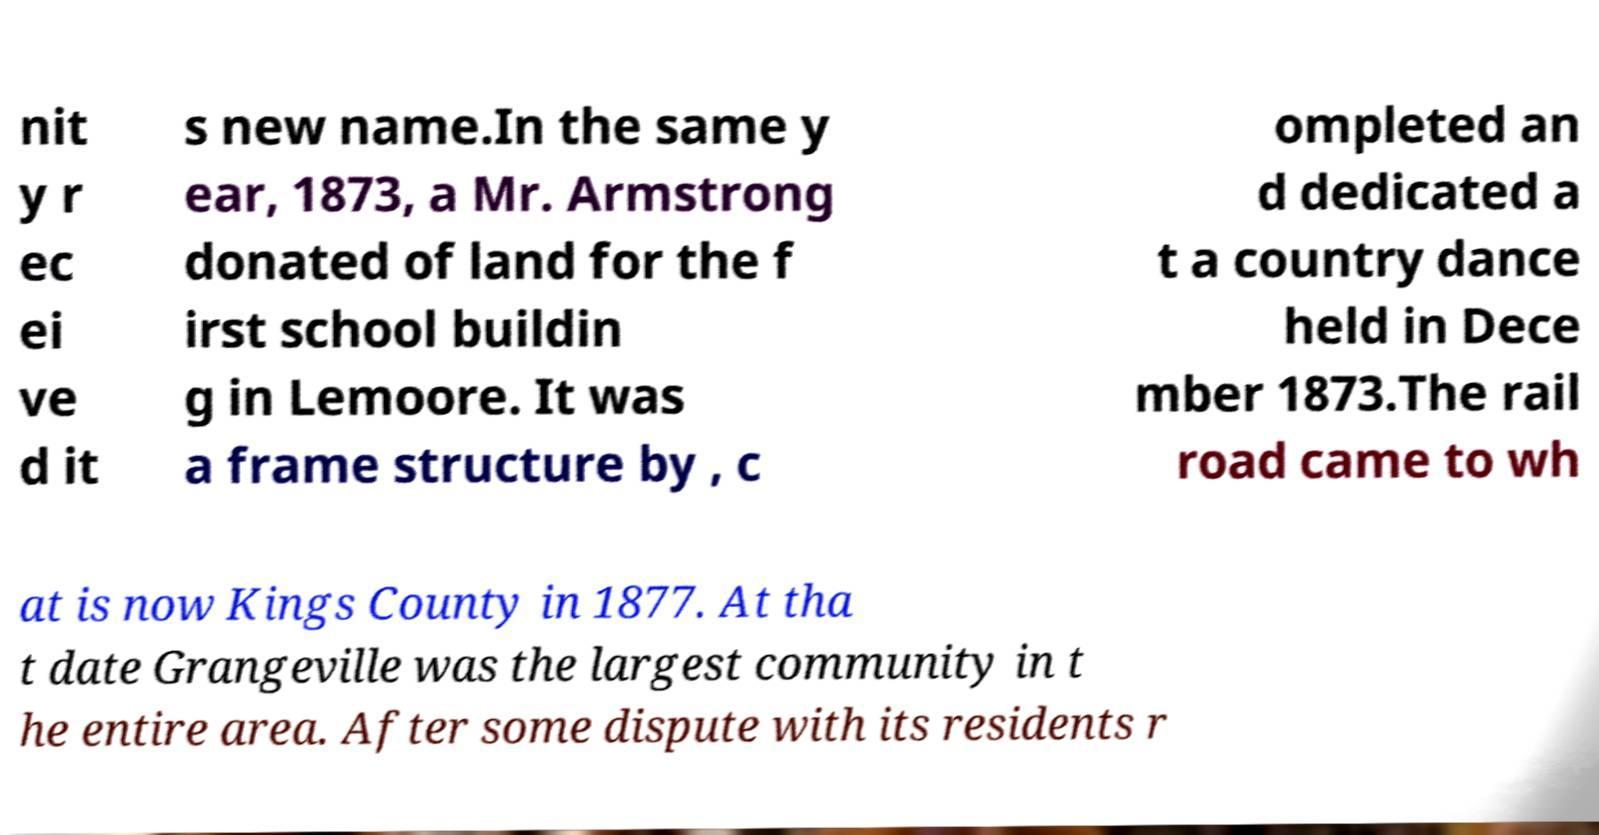Could you assist in decoding the text presented in this image and type it out clearly? nit y r ec ei ve d it s new name.In the same y ear, 1873, a Mr. Armstrong donated of land for the f irst school buildin g in Lemoore. It was a frame structure by , c ompleted an d dedicated a t a country dance held in Dece mber 1873.The rail road came to wh at is now Kings County in 1877. At tha t date Grangeville was the largest community in t he entire area. After some dispute with its residents r 